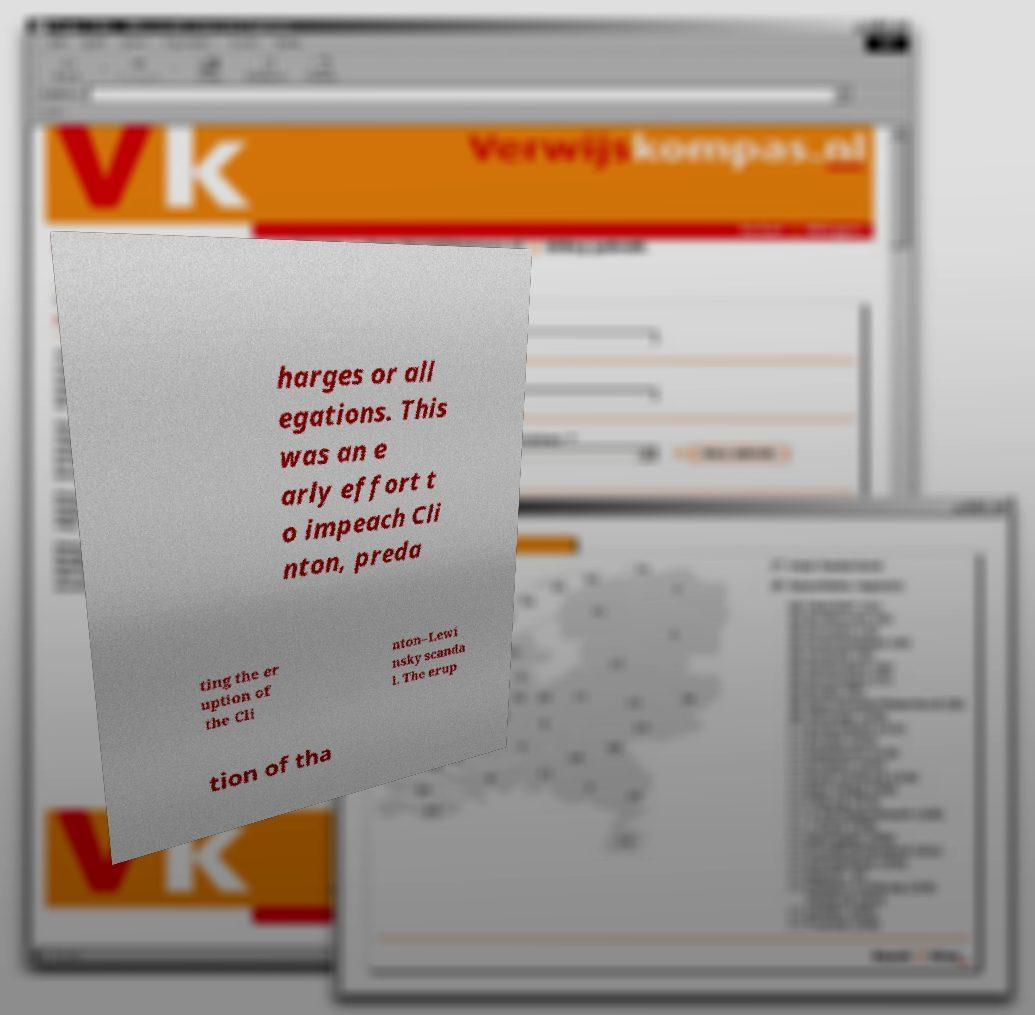Please read and relay the text visible in this image. What does it say? harges or all egations. This was an e arly effort t o impeach Cli nton, preda ting the er uption of the Cli nton–Lewi nsky scanda l. The erup tion of tha 